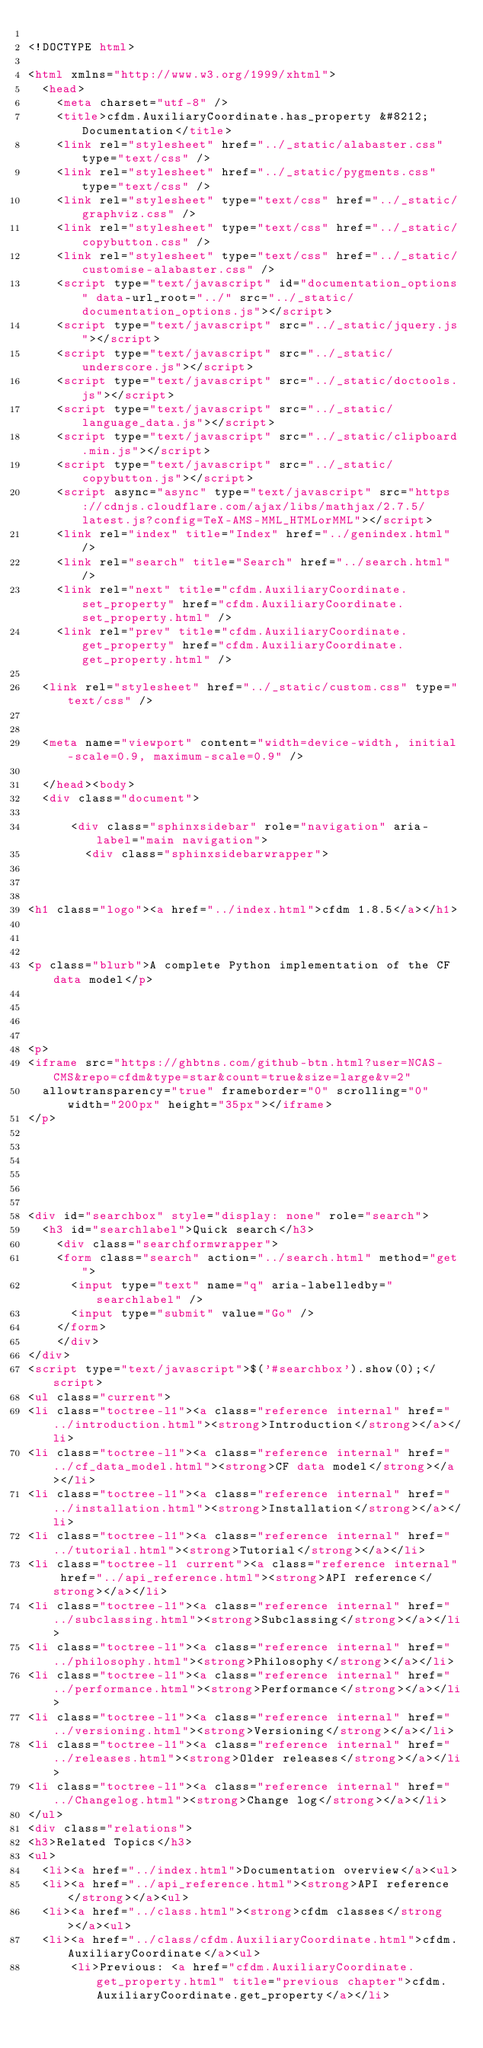Convert code to text. <code><loc_0><loc_0><loc_500><loc_500><_HTML_>
<!DOCTYPE html>

<html xmlns="http://www.w3.org/1999/xhtml">
  <head>
    <meta charset="utf-8" />
    <title>cfdm.AuxiliaryCoordinate.has_property &#8212; Documentation</title>
    <link rel="stylesheet" href="../_static/alabaster.css" type="text/css" />
    <link rel="stylesheet" href="../_static/pygments.css" type="text/css" />
    <link rel="stylesheet" type="text/css" href="../_static/graphviz.css" />
    <link rel="stylesheet" type="text/css" href="../_static/copybutton.css" />
    <link rel="stylesheet" type="text/css" href="../_static/customise-alabaster.css" />
    <script type="text/javascript" id="documentation_options" data-url_root="../" src="../_static/documentation_options.js"></script>
    <script type="text/javascript" src="../_static/jquery.js"></script>
    <script type="text/javascript" src="../_static/underscore.js"></script>
    <script type="text/javascript" src="../_static/doctools.js"></script>
    <script type="text/javascript" src="../_static/language_data.js"></script>
    <script type="text/javascript" src="../_static/clipboard.min.js"></script>
    <script type="text/javascript" src="../_static/copybutton.js"></script>
    <script async="async" type="text/javascript" src="https://cdnjs.cloudflare.com/ajax/libs/mathjax/2.7.5/latest.js?config=TeX-AMS-MML_HTMLorMML"></script>
    <link rel="index" title="Index" href="../genindex.html" />
    <link rel="search" title="Search" href="../search.html" />
    <link rel="next" title="cfdm.AuxiliaryCoordinate.set_property" href="cfdm.AuxiliaryCoordinate.set_property.html" />
    <link rel="prev" title="cfdm.AuxiliaryCoordinate.get_property" href="cfdm.AuxiliaryCoordinate.get_property.html" />
   
  <link rel="stylesheet" href="../_static/custom.css" type="text/css" />
  
  
  <meta name="viewport" content="width=device-width, initial-scale=0.9, maximum-scale=0.9" />

  </head><body>
  <div class="document">
    
      <div class="sphinxsidebar" role="navigation" aria-label="main navigation">
        <div class="sphinxsidebarwrapper">



<h1 class="logo"><a href="../index.html">cfdm 1.8.5</a></h1>



<p class="blurb">A complete Python implementation of the CF data model</p>




<p>
<iframe src="https://ghbtns.com/github-btn.html?user=NCAS-CMS&repo=cfdm&type=star&count=true&size=large&v=2"
  allowtransparency="true" frameborder="0" scrolling="0" width="200px" height="35px"></iframe>
</p>






<div id="searchbox" style="display: none" role="search">
  <h3 id="searchlabel">Quick search</h3>
    <div class="searchformwrapper">
    <form class="search" action="../search.html" method="get">
      <input type="text" name="q" aria-labelledby="searchlabel" />
      <input type="submit" value="Go" />
    </form>
    </div>
</div>
<script type="text/javascript">$('#searchbox').show(0);</script>
<ul class="current">
<li class="toctree-l1"><a class="reference internal" href="../introduction.html"><strong>Introduction</strong></a></li>
<li class="toctree-l1"><a class="reference internal" href="../cf_data_model.html"><strong>CF data model</strong></a></li>
<li class="toctree-l1"><a class="reference internal" href="../installation.html"><strong>Installation</strong></a></li>
<li class="toctree-l1"><a class="reference internal" href="../tutorial.html"><strong>Tutorial</strong></a></li>
<li class="toctree-l1 current"><a class="reference internal" href="../api_reference.html"><strong>API reference</strong></a></li>
<li class="toctree-l1"><a class="reference internal" href="../subclassing.html"><strong>Subclassing</strong></a></li>
<li class="toctree-l1"><a class="reference internal" href="../philosophy.html"><strong>Philosophy</strong></a></li>
<li class="toctree-l1"><a class="reference internal" href="../performance.html"><strong>Performance</strong></a></li>
<li class="toctree-l1"><a class="reference internal" href="../versioning.html"><strong>Versioning</strong></a></li>
<li class="toctree-l1"><a class="reference internal" href="../releases.html"><strong>Older releases</strong></a></li>
<li class="toctree-l1"><a class="reference internal" href="../Changelog.html"><strong>Change log</strong></a></li>
</ul>
<div class="relations">
<h3>Related Topics</h3>
<ul>
  <li><a href="../index.html">Documentation overview</a><ul>
  <li><a href="../api_reference.html"><strong>API reference</strong></a><ul>
  <li><a href="../class.html"><strong>cfdm classes</strong></a><ul>
  <li><a href="../class/cfdm.AuxiliaryCoordinate.html">cfdm.AuxiliaryCoordinate</a><ul>
      <li>Previous: <a href="cfdm.AuxiliaryCoordinate.get_property.html" title="previous chapter">cfdm.AuxiliaryCoordinate.get_property</a></li></code> 